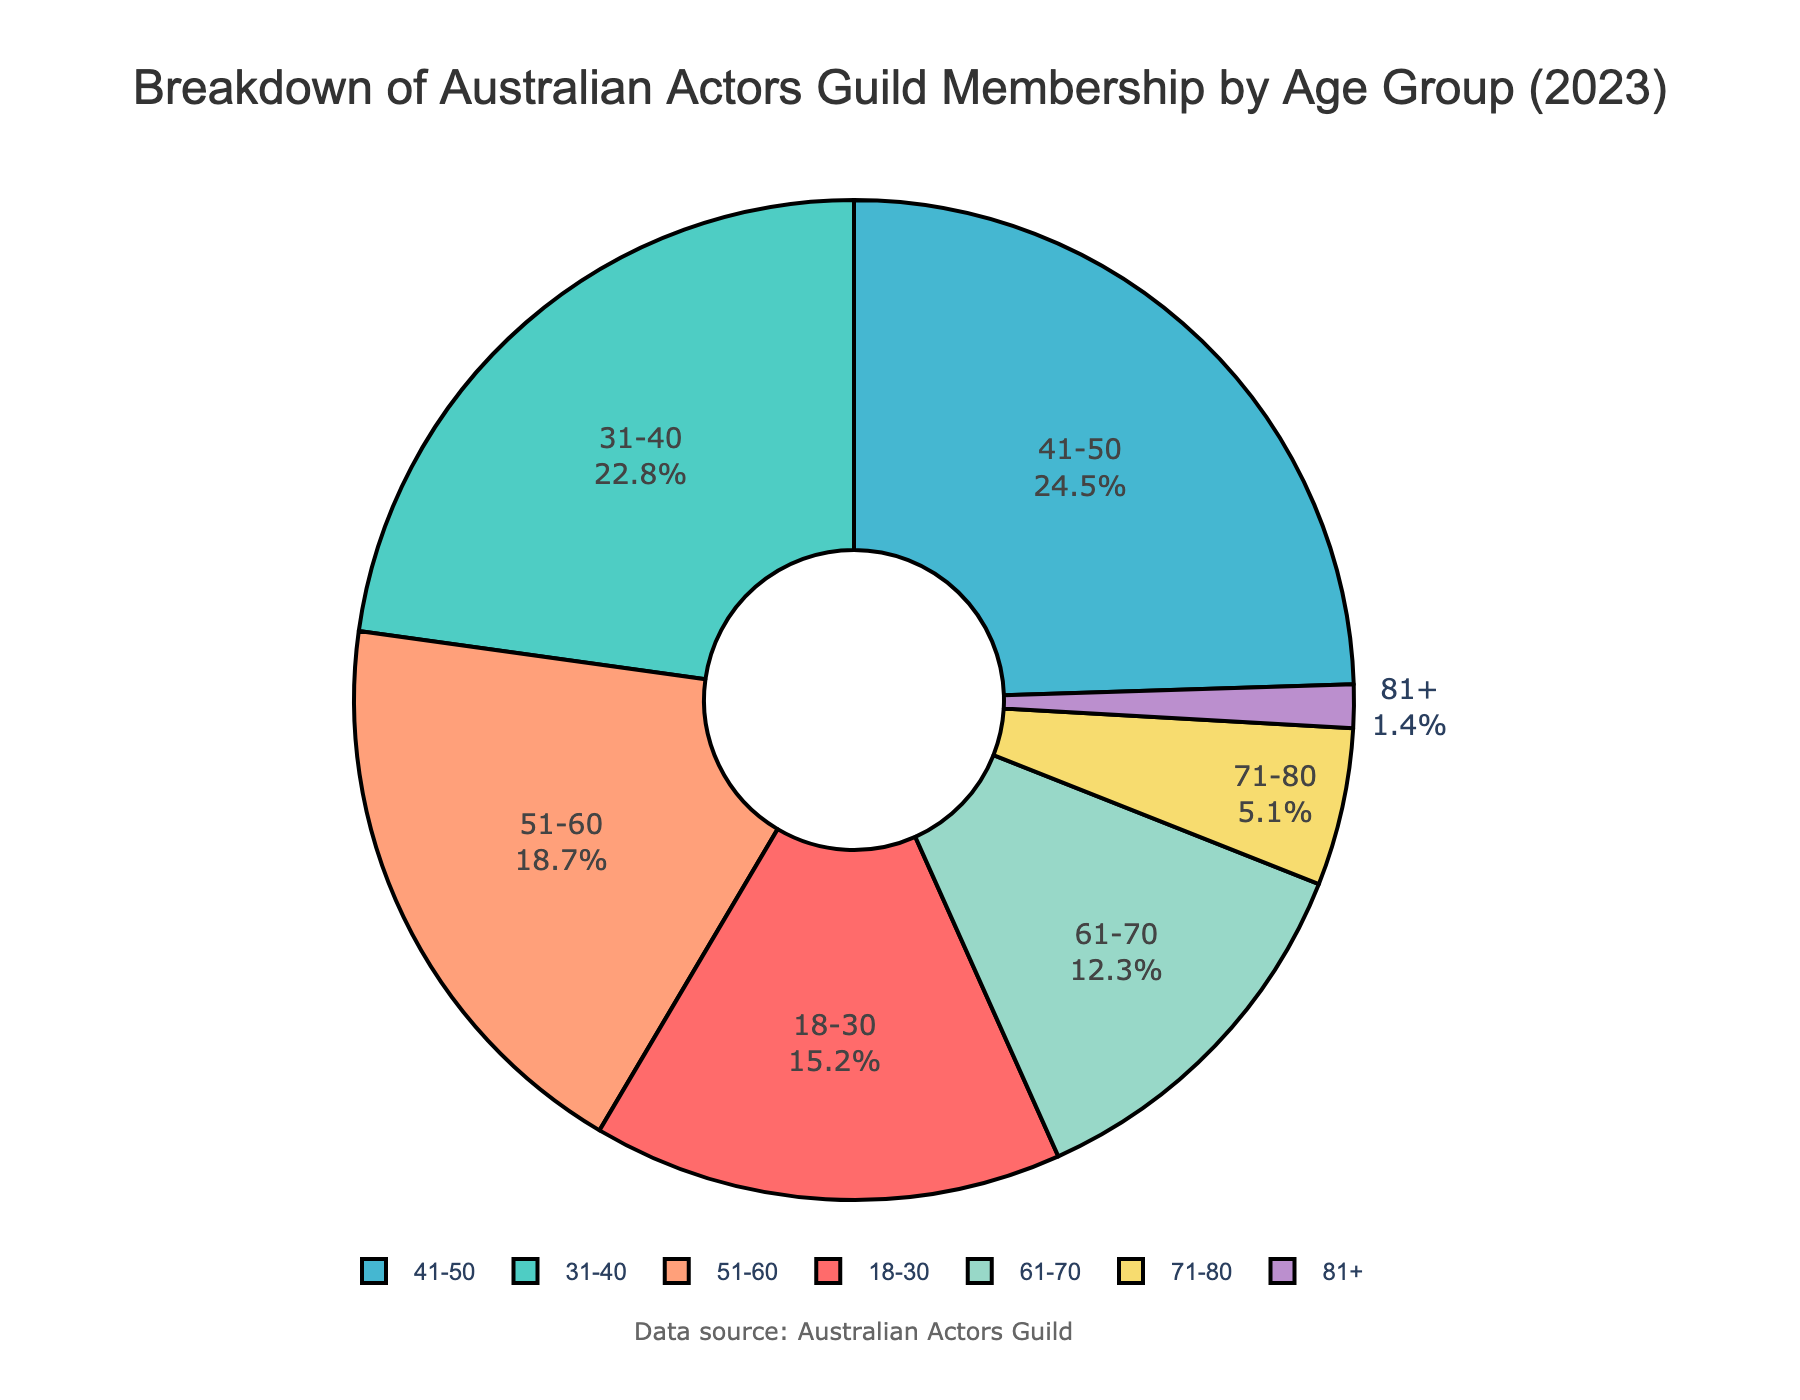What age group constitutes the largest percentage of the Australian Actors Guild membership in 2023? From the pie chart, the largest section corresponds to the 41-50 age group. This is visually the most significant portion and is also shown in the legend as 24.5%.
Answer: 41-50 Which age groups together make up more than half of the total membership? The age groups 41-50 and 31-40 make up 24.5% and 22.8%, respectively. Adding these percentages exceeds 50% (24.5% + 22.8% = 47.3%), and adding the next largest, 51-60, covers 66% total.
Answer: 41-50, 31-40, 51-60 Is the percentage of members aged 18-30 higher or lower than those aged 61-70? By comparing the two sections, the 18-30 age group has 15.2%, while the 61-70 age group has 12.3%. Thus, the 18-30 percentage is higher.
Answer: Higher What is the total percentage of members aged 51 and over? Summing the percentages for the age groups 51-60, 61-70, 71-80, and 81+ gives 18.7% + 12.3% + 5.1% + 1.4% = 37.5%.
Answer: 37.5% Which color represents the 31-40 age group? Observing the pie chart, the 31-40 age group is depicted in a distinctive greenish color.
Answer: Greenish What percentage more members does the 41-50 group have compared to the 71-80 group? The 41-50 group has 24.5%, and the 71-80 group has 5.1%. The difference is 24.5% - 5.1% = 19.4%.
Answer: 19.4% If the 81+ age group's percentage doubled, how would it compare to the 71-80 group? Doubling the 81+ percentage (1.4%) gives 2.8%, which is still less than the 71-80 group's 5.1%.
Answer: Less Are there more members in the 61-70 age group or the combined 71-80 and 81+ age groups? The 61-70 age group has 12.3%, while the combined 71-80 and 81+ groups have 5.1% + 1.4% = 6.5%. Therefore, the 61-70 group has more members.
Answer: 61-70 What is the average percentage of members in the age groups from 18-50? Adding the percentages for 18-30, 31-40, and 41-50 gives 15.2% + 22.8% + 24.5% = 62.5%. Dividing by 3 gives an average of 62.5% / 3 = 20.83%.
Answer: 20.83% Which age group has the smallest membership percentage, and what is it? The pie chart shows that the 81+ age group has the smallest section at 1.4%.
Answer: 81+, 1.4% 